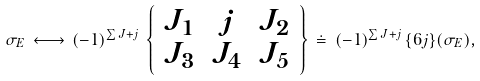Convert formula to latex. <formula><loc_0><loc_0><loc_500><loc_500>\sigma _ { E } \, \longleftrightarrow \, ( - 1 ) ^ { \sum J + j } \, \left \{ \begin{array} { c c c } { { J _ { 1 } } } & { j } & { { J _ { 2 } } } \\ { { J _ { 3 } } } & { { J _ { 4 } } } & { { J _ { 5 } } } \end{array} \right \} \, \doteq \, ( - 1 ) ^ { \sum J + j } \, \{ 6 j \} ( \sigma _ { E } ) ,</formula> 